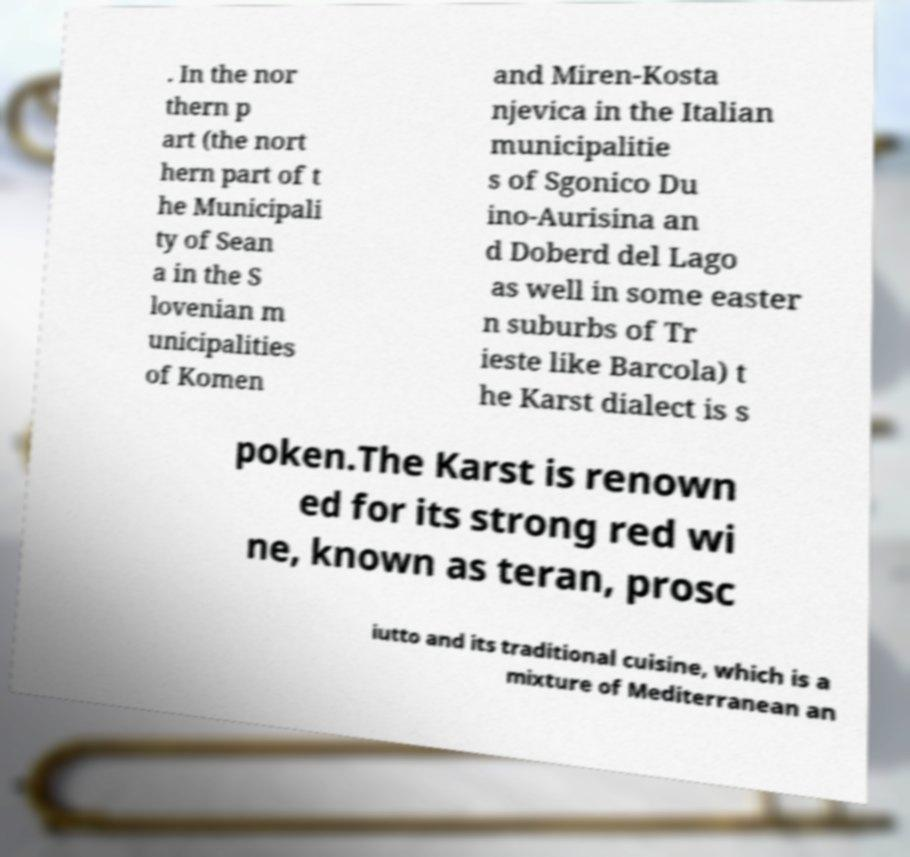What messages or text are displayed in this image? I need them in a readable, typed format. . In the nor thern p art (the nort hern part of t he Municipali ty of Sean a in the S lovenian m unicipalities of Komen and Miren-Kosta njevica in the Italian municipalitie s of Sgonico Du ino-Aurisina an d Doberd del Lago as well in some easter n suburbs of Tr ieste like Barcola) t he Karst dialect is s poken.The Karst is renown ed for its strong red wi ne, known as teran, prosc iutto and its traditional cuisine, which is a mixture of Mediterranean an 